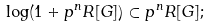<formula> <loc_0><loc_0><loc_500><loc_500>\log ( 1 + p ^ { n } R [ G ] ) \subset p ^ { n } R [ G ] ;</formula> 